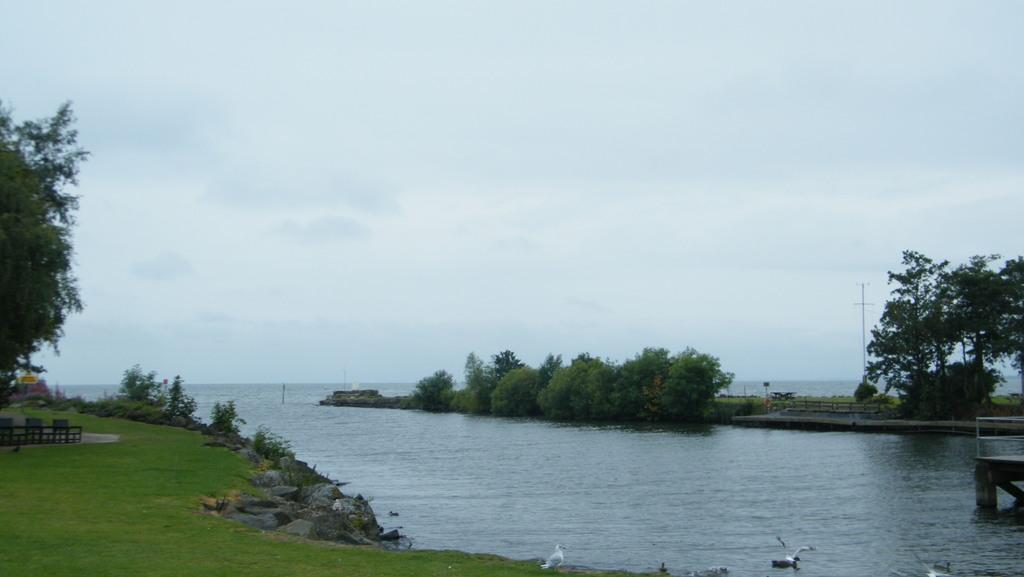What type of natural environment is depicted in the image? The image features a sea, plants, trees, grass, and stones, which are all elements of a natural environment. What type of vegetation can be seen in the image? The image includes plants, trees, and grass. What other objects can be seen in the image? There are rods and wooden objects visible in the image. What type of animals are present in the image? Birds can be seen in the image. What is visible in the background of the image? The sky is visible in the background of the image. Can you tell me how many houses are visible in the image? There are no houses present in the image; it features a natural environment with a sea, plants, trees, grass, stones, rods, wooden objects, and birds. What type of clothing can be seen on the birds in the image? There is no clothing visible on the birds in the image; they are not wearing jeans or any other type of clothing. 